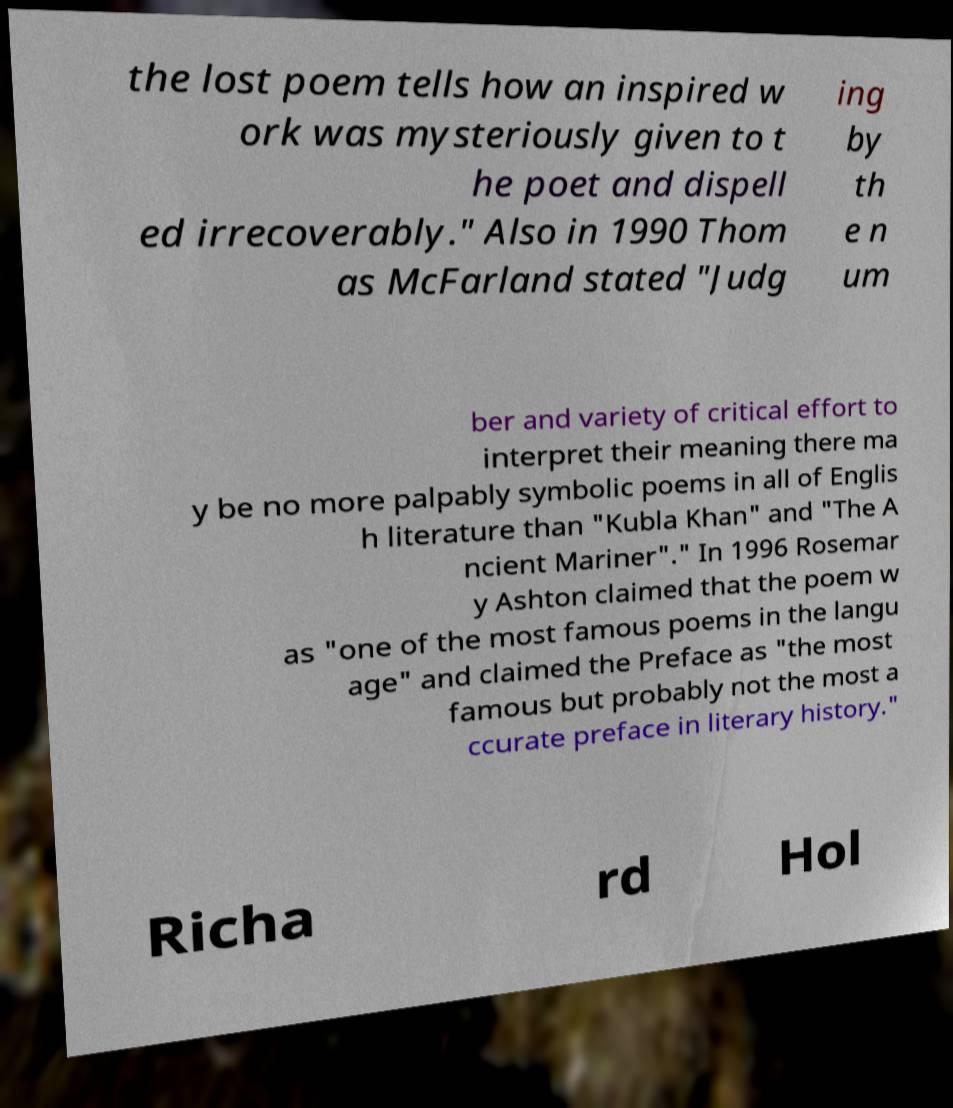Please identify and transcribe the text found in this image. the lost poem tells how an inspired w ork was mysteriously given to t he poet and dispell ed irrecoverably." Also in 1990 Thom as McFarland stated "Judg ing by th e n um ber and variety of critical effort to interpret their meaning there ma y be no more palpably symbolic poems in all of Englis h literature than "Kubla Khan" and "The A ncient Mariner"." In 1996 Rosemar y Ashton claimed that the poem w as "one of the most famous poems in the langu age" and claimed the Preface as "the most famous but probably not the most a ccurate preface in literary history." Richa rd Hol 